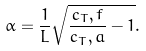<formula> <loc_0><loc_0><loc_500><loc_500>\alpha = \frac { 1 } { L } \sqrt { \frac { c _ { T } , f } { c _ { T } , a } - 1 } .</formula> 